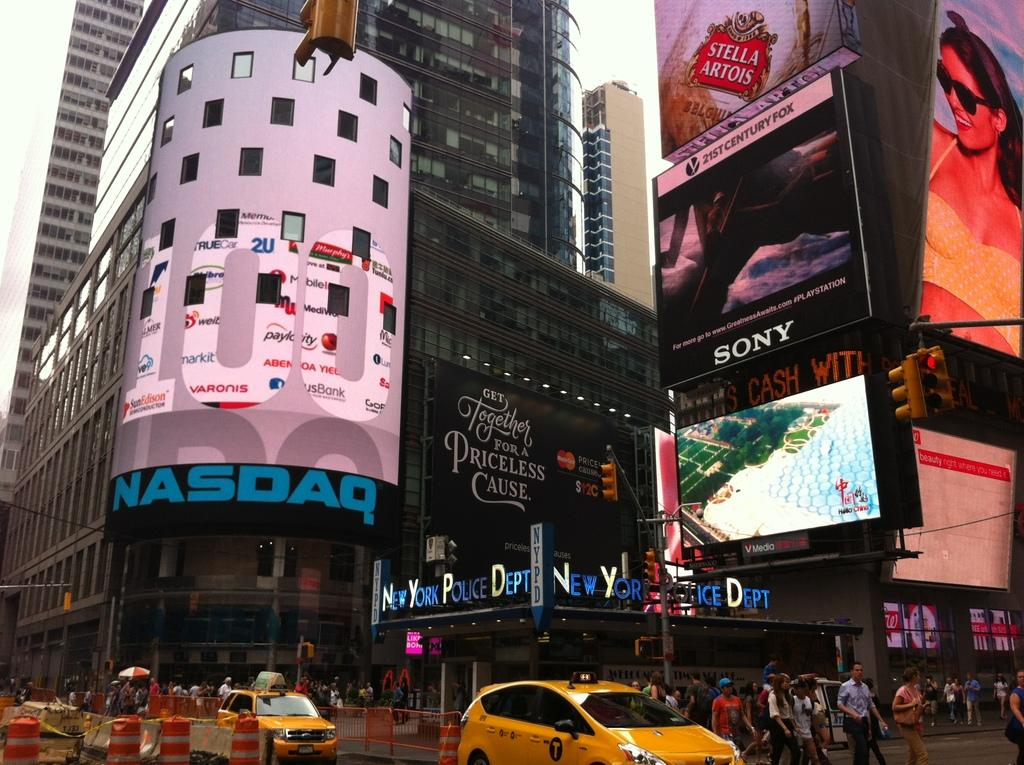<image>
Share a concise interpretation of the image provided. A street in New York City near the New York Police Department. 